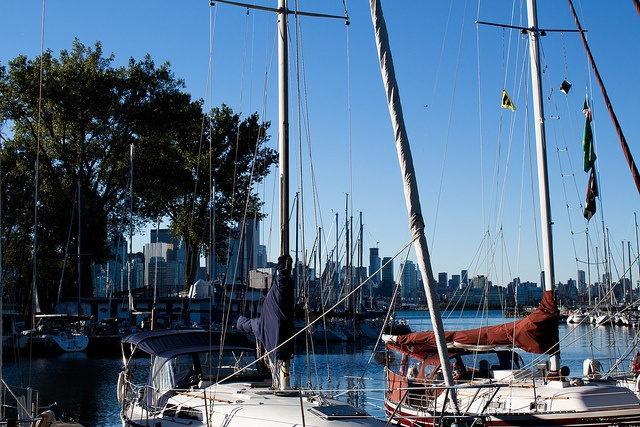Describe the objects in this image and their specific colors. I can see boat in darkgray, black, lightblue, and lightgray tones, boat in darkgray, black, white, gray, and maroon tones, boat in darkgray, black, navy, darkblue, and purple tones, boat in darkgray, black, white, and gray tones, and people in darkgray, black, blue, navy, and gray tones in this image. 